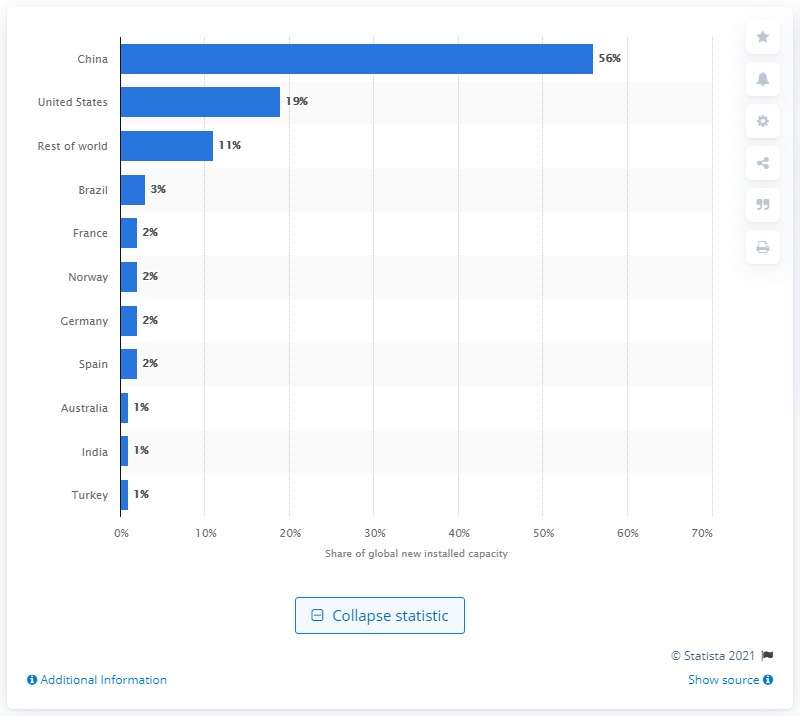Give some essential details in this illustration. In 2020, China accounted for 56% of the world's new onshore wind power capacity, making it the leading country in the world in terms of wind power capacity expansion. 